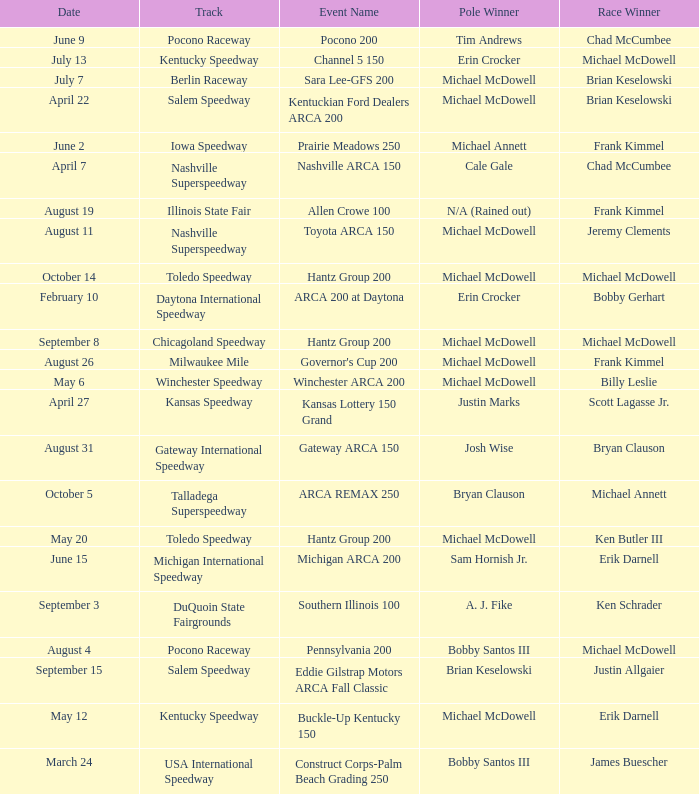Tell me the pole winner of may 12 Michael McDowell. 